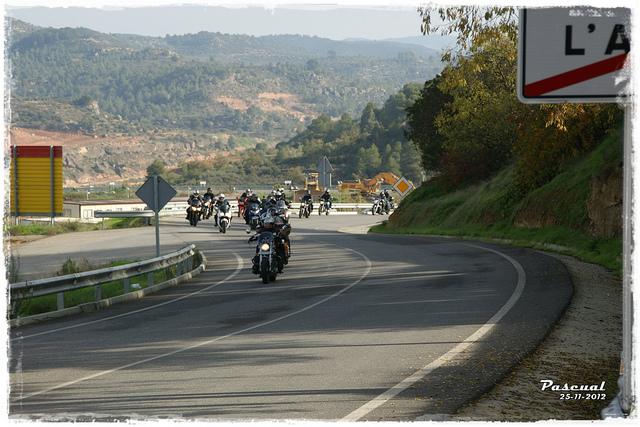Are there any cars on the road?
Keep it brief. No. Are the riders going up or down?
Keep it brief. Up. Is the road curving?
Answer briefly. Yes. 